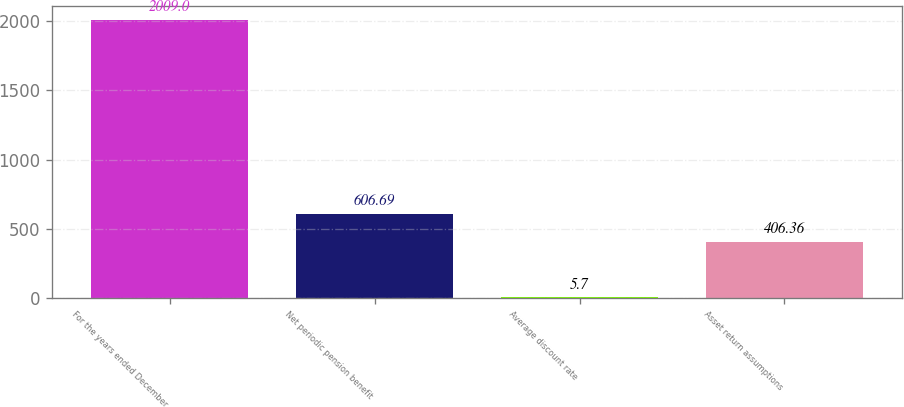<chart> <loc_0><loc_0><loc_500><loc_500><bar_chart><fcel>For the years ended December<fcel>Net periodic pension benefit<fcel>Average discount rate<fcel>Asset return assumptions<nl><fcel>2009<fcel>606.69<fcel>5.7<fcel>406.36<nl></chart> 